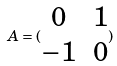Convert formula to latex. <formula><loc_0><loc_0><loc_500><loc_500>A = ( \begin{matrix} 0 & 1 \\ - 1 & 0 \end{matrix} )</formula> 